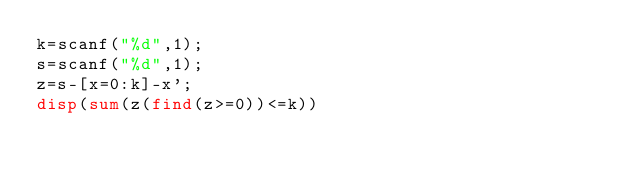<code> <loc_0><loc_0><loc_500><loc_500><_Octave_>k=scanf("%d",1);
s=scanf("%d",1);
z=s-[x=0:k]-x';                                                                 
disp(sum(z(find(z>=0))<=k))  </code> 